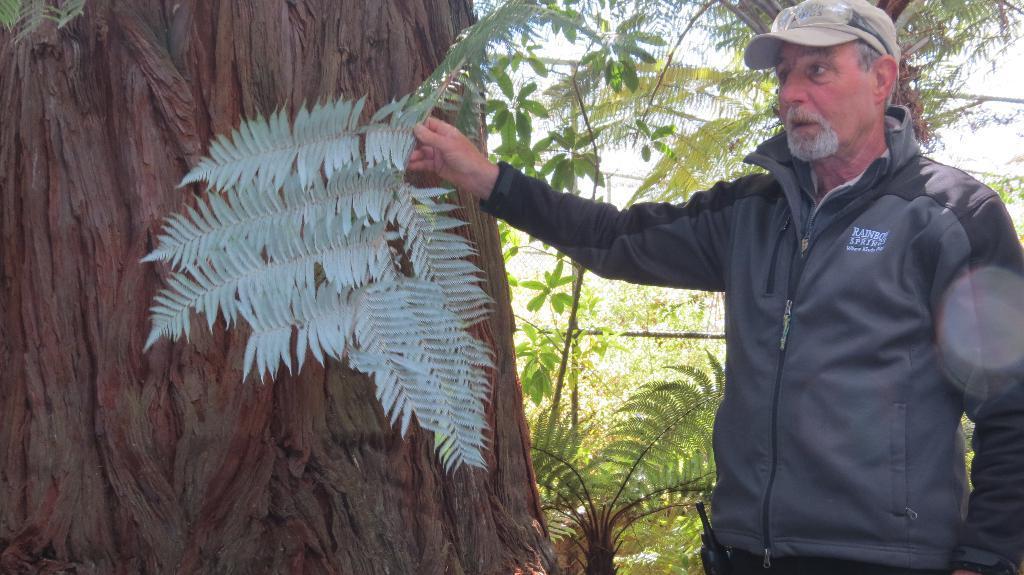Please provide a concise description of this image. To the right side corner of the image there is a man with black jacket and a cap on his head is standing and holding the leaves in his hand. Behind the leaves there is a tree trunk. And in the background there are many trees. 